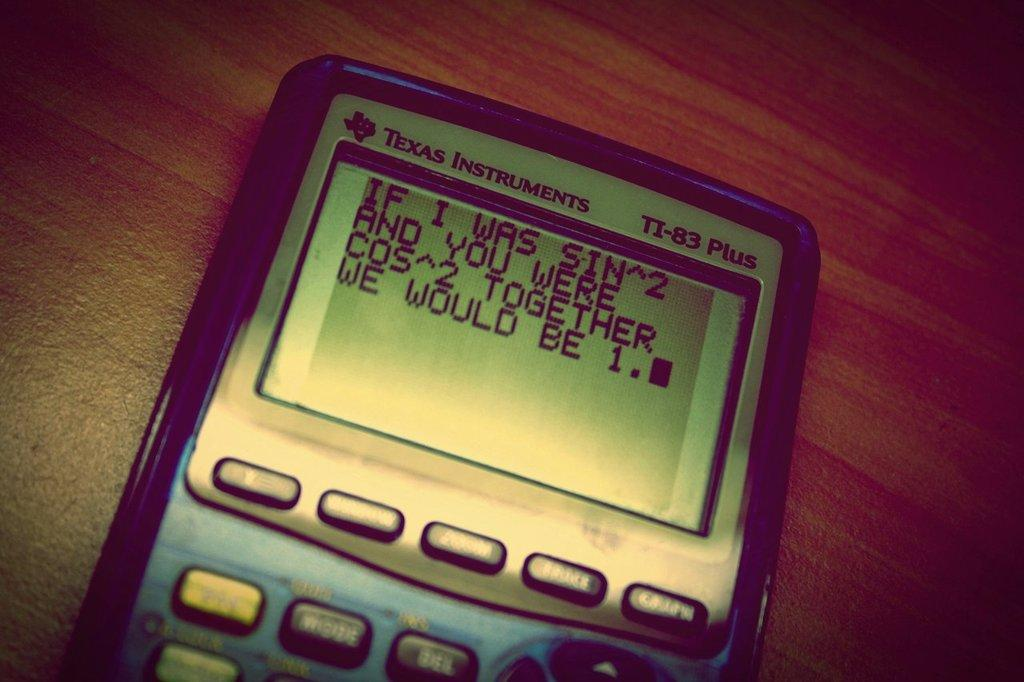<image>
Give a short and clear explanation of the subsequent image. A math joke is displayed on the screen of a Texas Instruments device. 